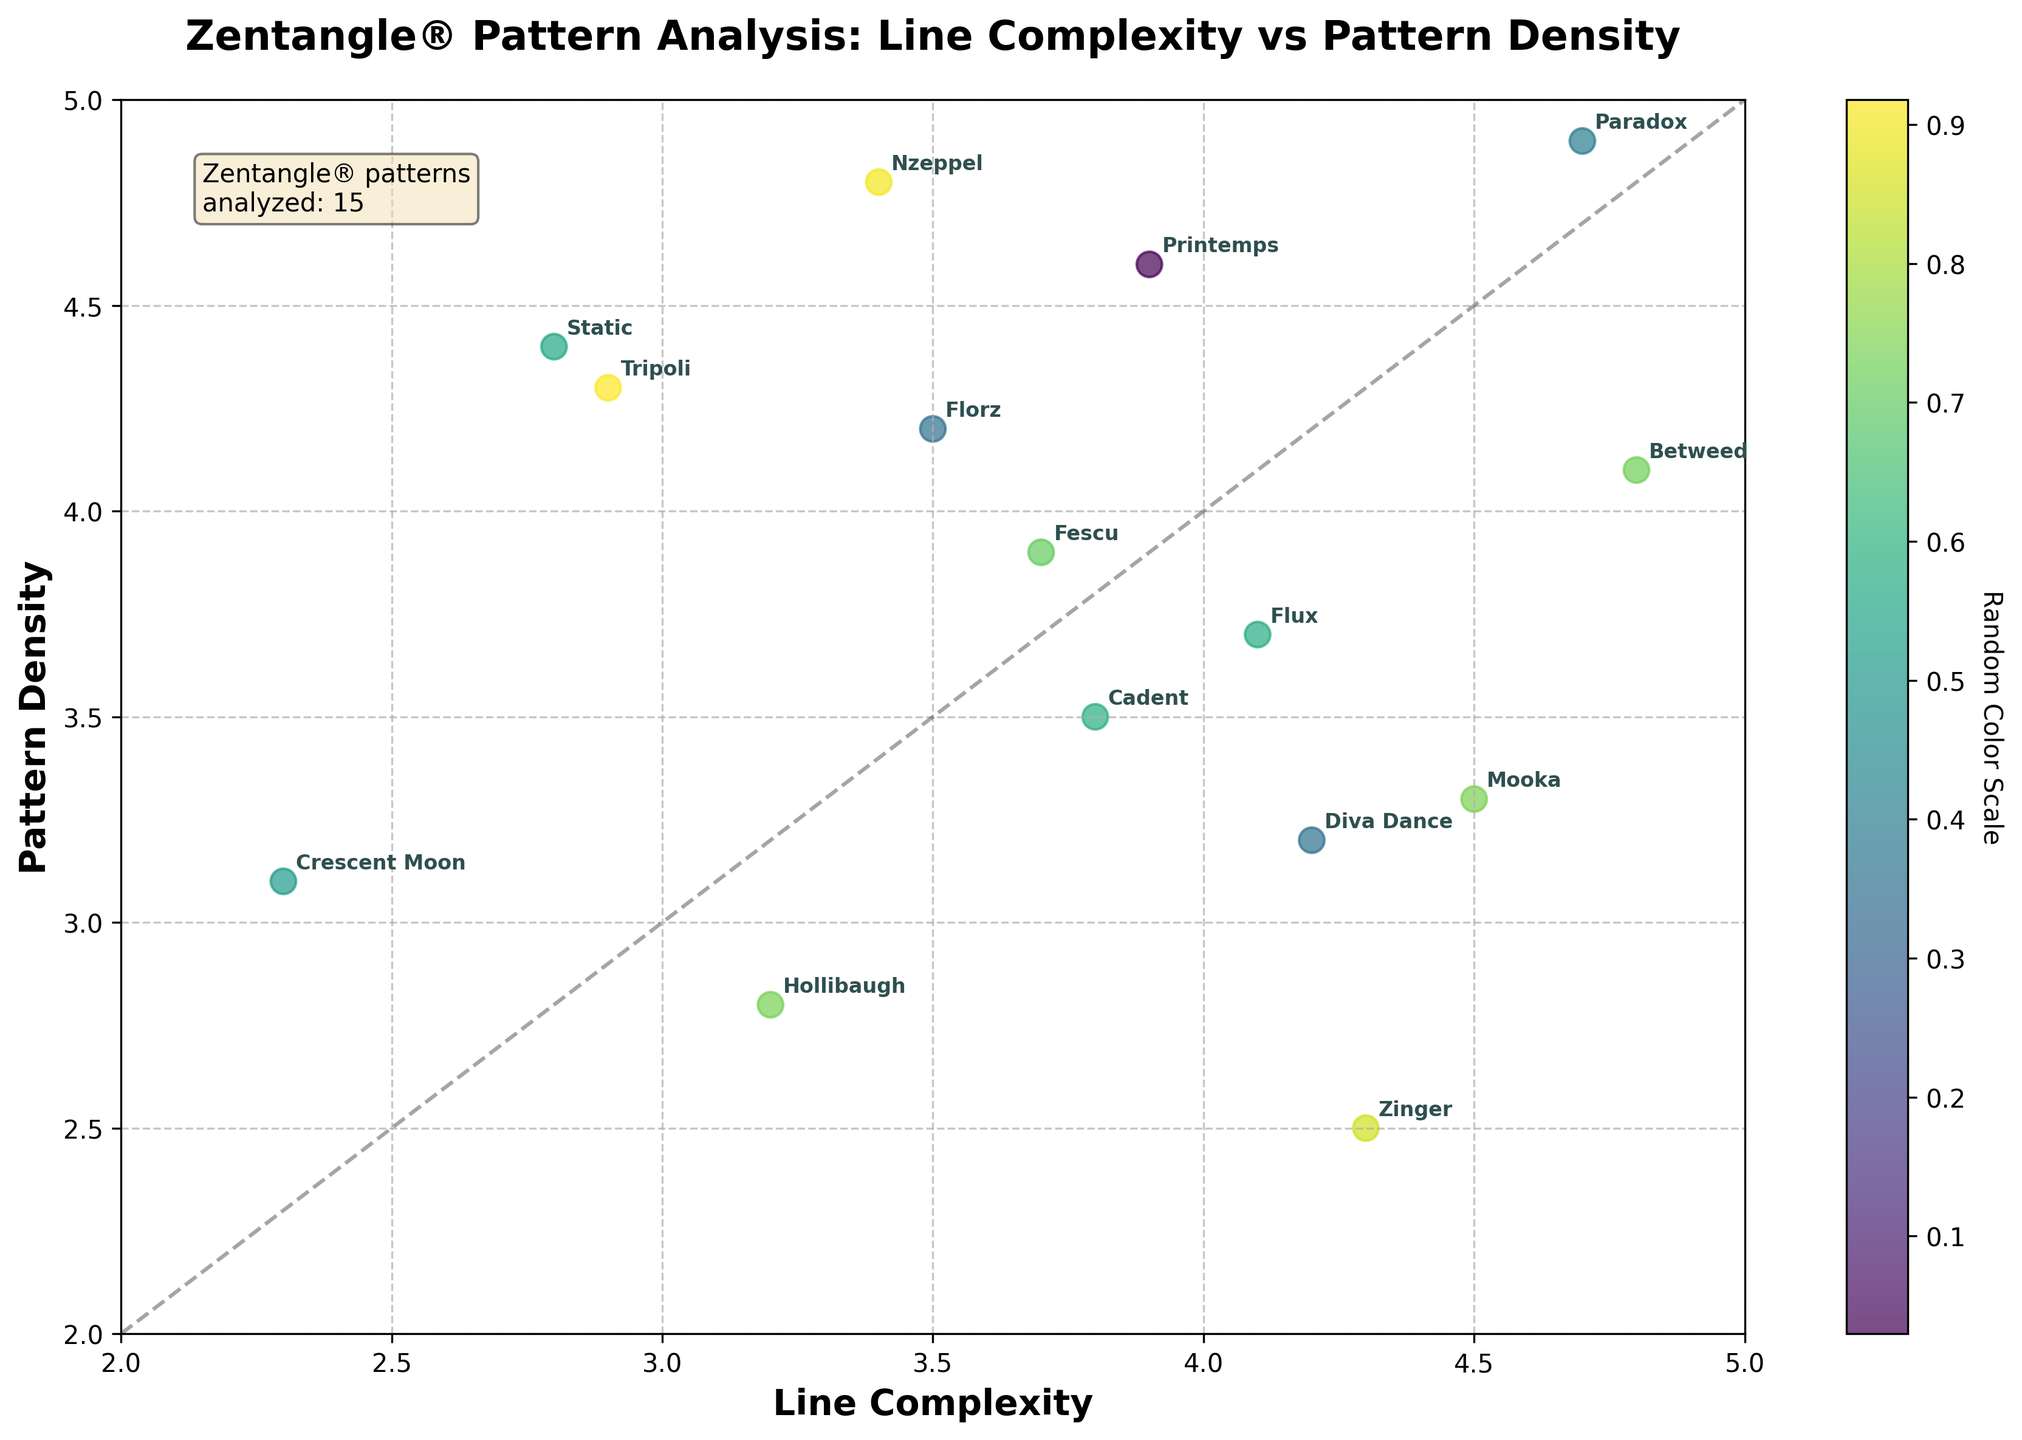How many Zentangle® patterns are analyzed in the figure? The information box in the top-left corner of the figure states "Zentangle® patterns analyzed: 15".
Answer: 15 What is the title of the figure? The title is located at the top of the figure and reads "Zentangle® Pattern Analysis: Line Complexity vs Pattern Density".
Answer: Zentangle® Pattern Analysis: Line Complexity vs Pattern Density Which pattern has the highest line complexity? The highest value on the x-axis (Line Complexity) is 4.8, which corresponds to the label "Betweed".
Answer: Betweed Which pattern has the lowest pattern density? The lowest value on the y-axis (Pattern Density) is 2.5, which corresponds to the label "Zinger".
Answer: Zinger Is there any pattern with both line complexity and pattern density greater than 4.0? By observing the scatter plot, "Paradox" and "Betweed" both have line complexity and pattern density values greater than 4.0.
Answer: Paradox, Betweed Which pattern is closest to the point (3, 3) on the plot? By looking at the plot, the pattern closest to (3, 3) is "Hollibaugh" with values (3.2, 2.8).
Answer: Hollibaugh What is the mean line complexity of the patterns with a pattern density less than 3.5? Patterns with density less than 3.5 are "Hollibaugh" (3.2), "Zinger" (4.3), "Mooka" (4.5), and "Diva Dance" (4.2). The mean line complexity is (3.2 + 4.3 + 4.5 + 4.2) / 4 = 4.05.
Answer: 4.05 What is the difference in pattern density between "Printemps" and "Static"? "Printemps" has a pattern density of 4.6 and "Static" has a pattern density of 4.4. The difference is 4.6 - 4.4 = 0.2.
Answer: 0.2 Which pattern is both high in line complexity and high in pattern density but doesn't have the highest values in either axis? "Flux" has high values in both line complexity (4.1) and pattern density (3.7) without having the highest in either category.
Answer: Flux How many patterns have a line complexity greater than the diagonal line y=x? Patterns with line complexity greater than pattern density (above the diagonal line y=x) are "Betweed", "Crescent Moon", "Fescu", "Mooka", "Zinger", and "Diva Dance". There are 6 patterns.
Answer: 6 